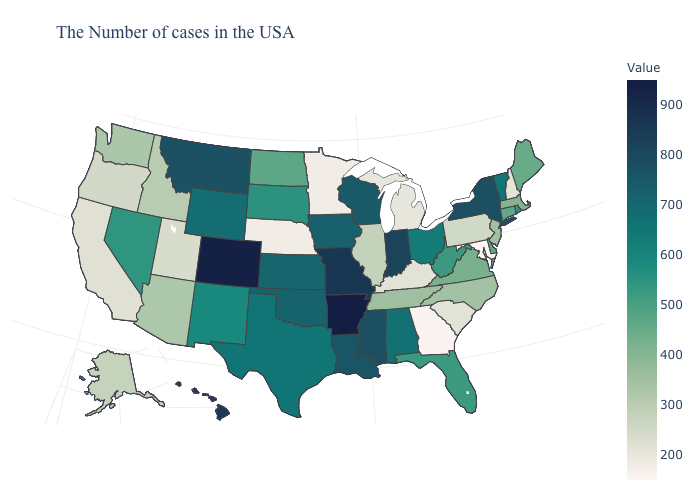Does Alaska have the lowest value in the West?
Keep it brief. No. Among the states that border Arkansas , which have the lowest value?
Keep it brief. Tennessee. Does Indiana have the highest value in the USA?
Give a very brief answer. No. Does Colorado have the highest value in the West?
Be succinct. Yes. Does Rhode Island have the lowest value in the Northeast?
Short answer required. No. 